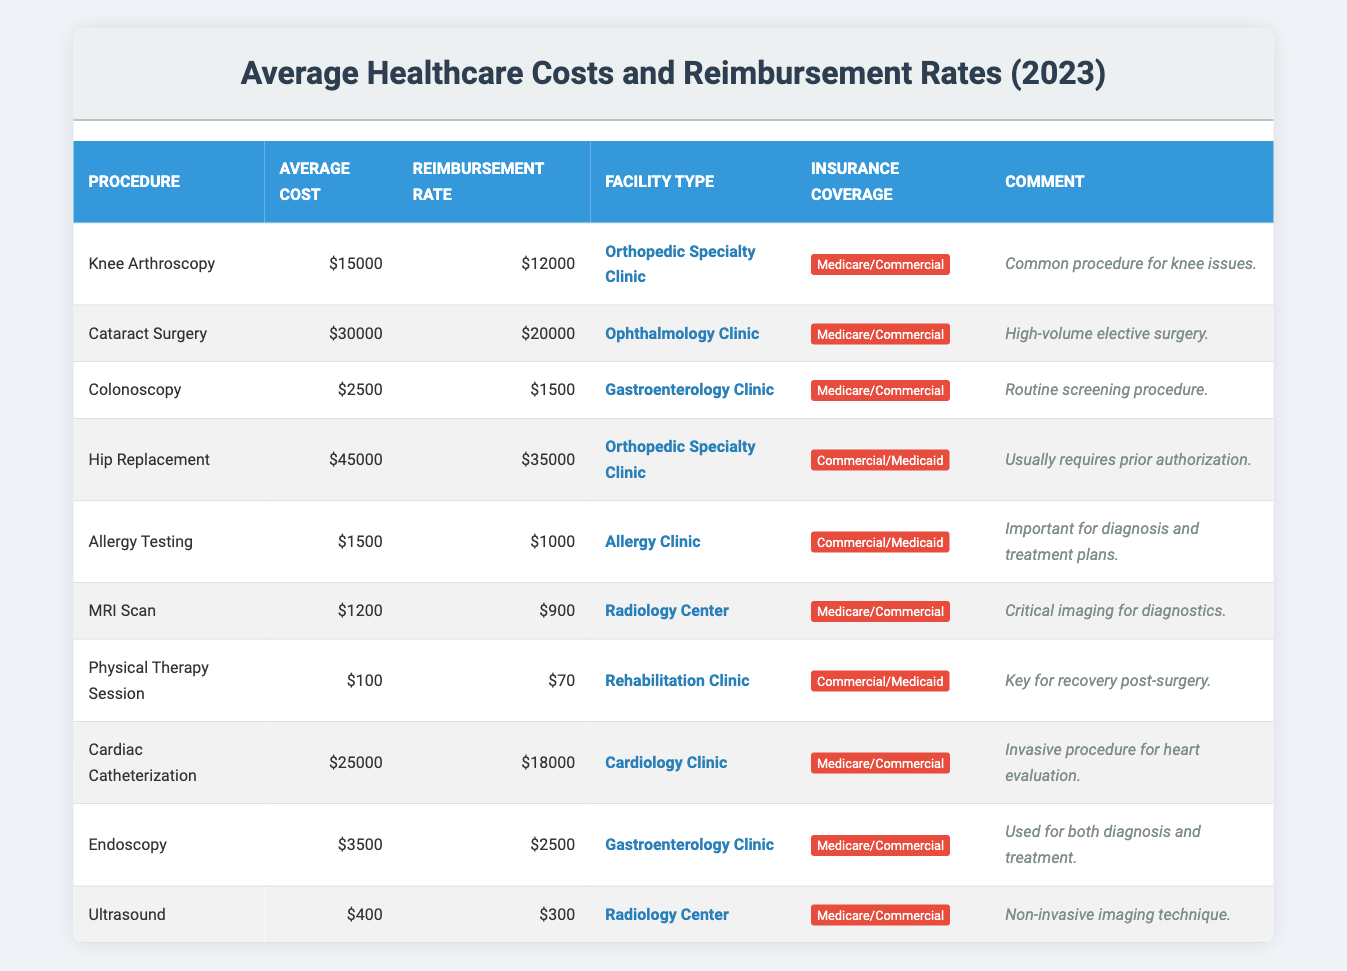What is the average cost of Knee Arthroscopy? The table indicates that the average cost for Knee Arthroscopy is listed as 15000.
Answer: 15000 What is the reimbursement rate for Hip Replacement? According to the table, the reimbursement rate for Hip Replacement is 35000.
Answer: 35000 How much less is the reimbursement rate for Colonoscopy compared to its average cost? The average cost for Colonoscopy is 2500, and the reimbursement rate is 1500. The difference is 2500 - 1500 = 1000.
Answer: 1000 Which facility type has the highest average cost procedure? By checking the average costs, Hip Replacement at 45000 has the highest average cost among the listed procedures.
Answer: Orthopedic Specialty Clinic Is the reimbursement rate for MRI Scan higher than its average cost? The average cost of MRI Scan is 1200, and the reimbursement rate is 900. Since 900 < 1200, the reimbursement rate is not higher.
Answer: No What is the total average cost for all procedures in Gastroenterology Clinic? The procedures for Gastroenterology Clinic are Colonoscopy (2500) and Endoscopy (3500). Summing these gives 2500 + 3500 = 6000.
Answer: 6000 Does Allergy Testing have a higher reimbursement rate than the MRI Scan? Allergy Testing has a reimbursement rate of 1000, while MRI Scan has a reimbursement rate of 900. Since 1000 > 900, Allergy Testing does have a higher reimbursement rate.
Answer: Yes What is the average reimbursement rate for procedures performed in an Orthopedic Specialty Clinic? The procedures at Orthopedic Specialty Clinic are Knee Arthroscopy (12000) and Hip Replacement (35000). The average reimbursement rate is (12000 + 35000) / 2 = 23500.
Answer: 23500 Which procedure has the lowest reimbursement rate relative to its average cost? Colonoscopy shows an average cost of 2500 and a reimbursement rate of 1500, giving a percentage of (1500/2500) * 100 = 60%. Comparing all procedures, Physical Therapy Session has a reimbursement rate of 70 compared to an average cost of 100, which is 70%. Therefore, Colonoscopy has the lowest in terms of reimbursement relative to its cost.
Answer: Colonoscopy How much more does Cataract Surgery cost than the reimbursement rate? The average cost of Cataract Surgery is 30000, and the reimbursement rate is 20000. The difference is 30000 - 20000 = 10000.
Answer: 10000 